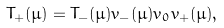Convert formula to latex. <formula><loc_0><loc_0><loc_500><loc_500>T _ { + } ( \mu ) = T _ { - } ( \mu ) v _ { - } ( \mu ) v _ { 0 } v _ { + } ( \mu ) ,</formula> 